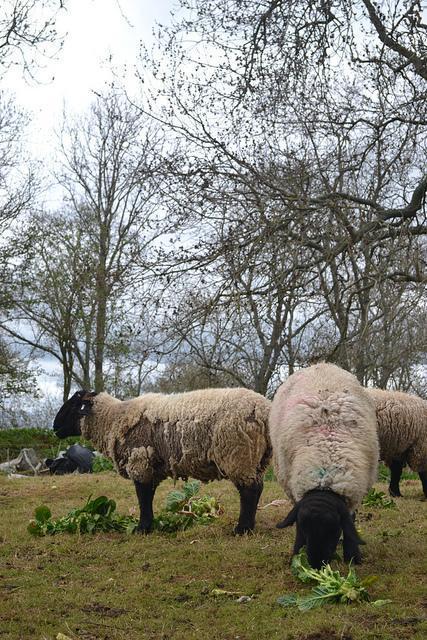How many sheeps are seen?
Give a very brief answer. 3. How many sheep are there?
Give a very brief answer. 3. 